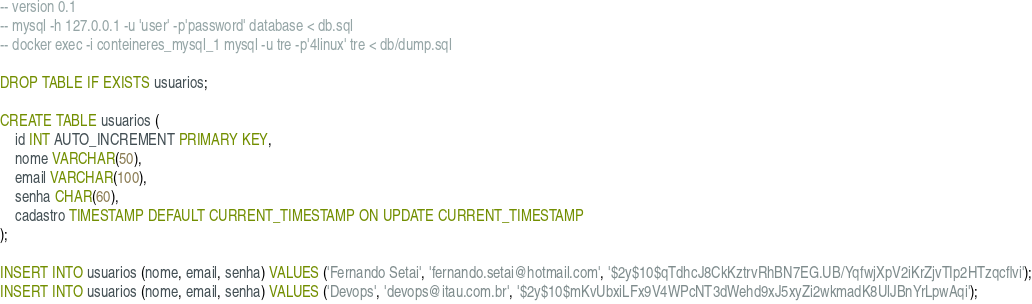Convert code to text. <code><loc_0><loc_0><loc_500><loc_500><_SQL_>-- version 0.1
-- mysql -h 127.0.0.1 -u 'user' -p'password' database < db.sql
-- docker exec -i conteineres_mysql_1 mysql -u tre -p'4linux' tre < db/dump.sql

DROP TABLE IF EXISTS usuarios;

CREATE TABLE usuarios (
	id INT AUTO_INCREMENT PRIMARY KEY,
	nome VARCHAR(50),
	email VARCHAR(100),
	senha CHAR(60),
	cadastro TIMESTAMP DEFAULT CURRENT_TIMESTAMP ON UPDATE CURRENT_TIMESTAMP
);

INSERT INTO usuarios (nome, email, senha) VALUES ('Fernando Setai', 'fernando.setai@hotmail.com', '$2y$10$qTdhcJ8CkKztrvRhBN7EG.UB/YqfwjXpV2iKrZjvTIp2HTzqcflvi');
INSERT INTO usuarios (nome, email, senha) VALUES ('Devops', 'devops@itau.com.br', '$2y$10$mKvUbxiLFx9V4WPcNT3dWehd9xJ5xyZi2wkmadK8UlJBnYrLpwAqi');
</code> 